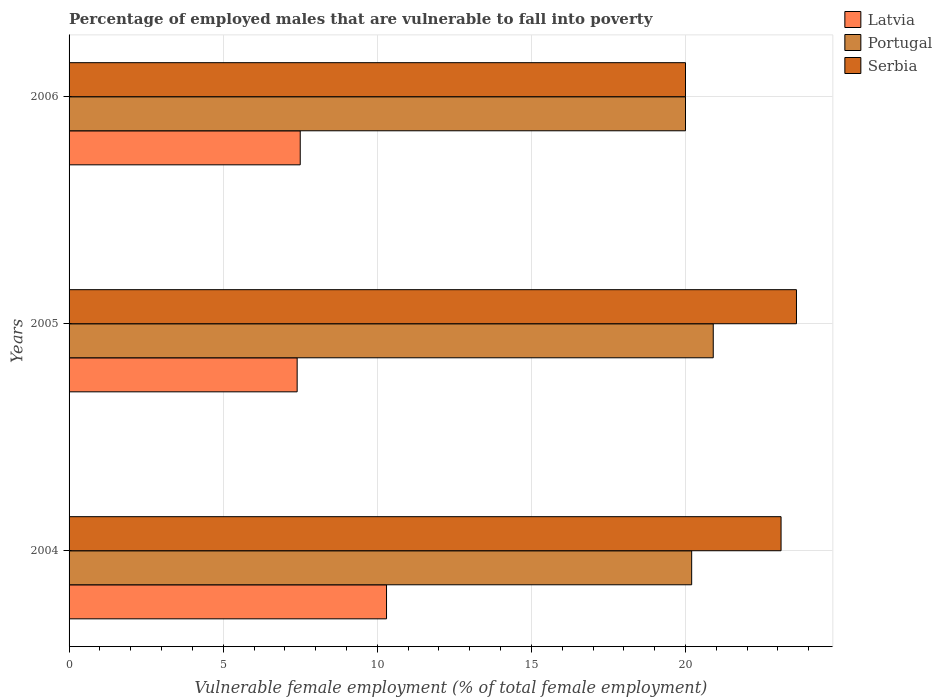How many different coloured bars are there?
Offer a terse response. 3. How many groups of bars are there?
Give a very brief answer. 3. Are the number of bars on each tick of the Y-axis equal?
Your answer should be compact. Yes. How many bars are there on the 2nd tick from the top?
Your answer should be very brief. 3. What is the label of the 1st group of bars from the top?
Keep it short and to the point. 2006. In how many cases, is the number of bars for a given year not equal to the number of legend labels?
Offer a terse response. 0. What is the percentage of employed males who are vulnerable to fall into poverty in Latvia in 2006?
Your response must be concise. 7.5. Across all years, what is the maximum percentage of employed males who are vulnerable to fall into poverty in Serbia?
Your response must be concise. 23.6. Across all years, what is the minimum percentage of employed males who are vulnerable to fall into poverty in Latvia?
Ensure brevity in your answer.  7.4. In which year was the percentage of employed males who are vulnerable to fall into poverty in Latvia minimum?
Ensure brevity in your answer.  2005. What is the total percentage of employed males who are vulnerable to fall into poverty in Latvia in the graph?
Offer a terse response. 25.2. What is the difference between the percentage of employed males who are vulnerable to fall into poverty in Latvia in 2004 and the percentage of employed males who are vulnerable to fall into poverty in Portugal in 2006?
Provide a short and direct response. -9.7. What is the average percentage of employed males who are vulnerable to fall into poverty in Portugal per year?
Your answer should be compact. 20.37. In the year 2004, what is the difference between the percentage of employed males who are vulnerable to fall into poverty in Serbia and percentage of employed males who are vulnerable to fall into poverty in Portugal?
Offer a very short reply. 2.9. In how many years, is the percentage of employed males who are vulnerable to fall into poverty in Portugal greater than 5 %?
Ensure brevity in your answer.  3. What is the ratio of the percentage of employed males who are vulnerable to fall into poverty in Portugal in 2004 to that in 2006?
Provide a succinct answer. 1.01. What is the difference between the highest and the second highest percentage of employed males who are vulnerable to fall into poverty in Latvia?
Keep it short and to the point. 2.8. What is the difference between the highest and the lowest percentage of employed males who are vulnerable to fall into poverty in Portugal?
Your answer should be compact. 0.9. In how many years, is the percentage of employed males who are vulnerable to fall into poverty in Serbia greater than the average percentage of employed males who are vulnerable to fall into poverty in Serbia taken over all years?
Offer a very short reply. 2. Is the sum of the percentage of employed males who are vulnerable to fall into poverty in Serbia in 2004 and 2005 greater than the maximum percentage of employed males who are vulnerable to fall into poverty in Latvia across all years?
Ensure brevity in your answer.  Yes. What does the 3rd bar from the top in 2004 represents?
Offer a terse response. Latvia. What does the 1st bar from the bottom in 2005 represents?
Keep it short and to the point. Latvia. Is it the case that in every year, the sum of the percentage of employed males who are vulnerable to fall into poverty in Portugal and percentage of employed males who are vulnerable to fall into poverty in Latvia is greater than the percentage of employed males who are vulnerable to fall into poverty in Serbia?
Offer a terse response. Yes. How many years are there in the graph?
Make the answer very short. 3. Does the graph contain any zero values?
Keep it short and to the point. No. Does the graph contain grids?
Provide a short and direct response. Yes. What is the title of the graph?
Ensure brevity in your answer.  Percentage of employed males that are vulnerable to fall into poverty. Does "Faeroe Islands" appear as one of the legend labels in the graph?
Provide a succinct answer. No. What is the label or title of the X-axis?
Give a very brief answer. Vulnerable female employment (% of total female employment). What is the label or title of the Y-axis?
Your answer should be very brief. Years. What is the Vulnerable female employment (% of total female employment) of Latvia in 2004?
Give a very brief answer. 10.3. What is the Vulnerable female employment (% of total female employment) of Portugal in 2004?
Offer a terse response. 20.2. What is the Vulnerable female employment (% of total female employment) in Serbia in 2004?
Your response must be concise. 23.1. What is the Vulnerable female employment (% of total female employment) in Latvia in 2005?
Offer a very short reply. 7.4. What is the Vulnerable female employment (% of total female employment) of Portugal in 2005?
Provide a succinct answer. 20.9. What is the Vulnerable female employment (% of total female employment) in Serbia in 2005?
Provide a short and direct response. 23.6. What is the Vulnerable female employment (% of total female employment) in Portugal in 2006?
Give a very brief answer. 20. Across all years, what is the maximum Vulnerable female employment (% of total female employment) of Latvia?
Your answer should be very brief. 10.3. Across all years, what is the maximum Vulnerable female employment (% of total female employment) in Portugal?
Provide a succinct answer. 20.9. Across all years, what is the maximum Vulnerable female employment (% of total female employment) of Serbia?
Your answer should be very brief. 23.6. Across all years, what is the minimum Vulnerable female employment (% of total female employment) in Latvia?
Your answer should be very brief. 7.4. What is the total Vulnerable female employment (% of total female employment) in Latvia in the graph?
Your response must be concise. 25.2. What is the total Vulnerable female employment (% of total female employment) of Portugal in the graph?
Your answer should be very brief. 61.1. What is the total Vulnerable female employment (% of total female employment) in Serbia in the graph?
Your answer should be very brief. 66.7. What is the difference between the Vulnerable female employment (% of total female employment) of Latvia in 2004 and that in 2005?
Offer a very short reply. 2.9. What is the difference between the Vulnerable female employment (% of total female employment) of Portugal in 2004 and that in 2005?
Make the answer very short. -0.7. What is the difference between the Vulnerable female employment (% of total female employment) in Serbia in 2004 and that in 2005?
Make the answer very short. -0.5. What is the difference between the Vulnerable female employment (% of total female employment) of Latvia in 2004 and that in 2006?
Provide a short and direct response. 2.8. What is the difference between the Vulnerable female employment (% of total female employment) in Serbia in 2004 and that in 2006?
Give a very brief answer. 3.1. What is the difference between the Vulnerable female employment (% of total female employment) of Portugal in 2005 and that in 2006?
Provide a succinct answer. 0.9. What is the difference between the Vulnerable female employment (% of total female employment) of Serbia in 2005 and that in 2006?
Your answer should be compact. 3.6. What is the difference between the Vulnerable female employment (% of total female employment) in Latvia in 2004 and the Vulnerable female employment (% of total female employment) in Portugal in 2005?
Ensure brevity in your answer.  -10.6. What is the difference between the Vulnerable female employment (% of total female employment) of Portugal in 2004 and the Vulnerable female employment (% of total female employment) of Serbia in 2005?
Give a very brief answer. -3.4. What is the difference between the Vulnerable female employment (% of total female employment) of Latvia in 2004 and the Vulnerable female employment (% of total female employment) of Portugal in 2006?
Make the answer very short. -9.7. What is the difference between the Vulnerable female employment (% of total female employment) in Portugal in 2004 and the Vulnerable female employment (% of total female employment) in Serbia in 2006?
Keep it short and to the point. 0.2. What is the difference between the Vulnerable female employment (% of total female employment) of Latvia in 2005 and the Vulnerable female employment (% of total female employment) of Portugal in 2006?
Keep it short and to the point. -12.6. What is the difference between the Vulnerable female employment (% of total female employment) of Latvia in 2005 and the Vulnerable female employment (% of total female employment) of Serbia in 2006?
Ensure brevity in your answer.  -12.6. What is the average Vulnerable female employment (% of total female employment) in Latvia per year?
Give a very brief answer. 8.4. What is the average Vulnerable female employment (% of total female employment) of Portugal per year?
Keep it short and to the point. 20.37. What is the average Vulnerable female employment (% of total female employment) in Serbia per year?
Ensure brevity in your answer.  22.23. In the year 2004, what is the difference between the Vulnerable female employment (% of total female employment) in Latvia and Vulnerable female employment (% of total female employment) in Portugal?
Make the answer very short. -9.9. In the year 2004, what is the difference between the Vulnerable female employment (% of total female employment) in Portugal and Vulnerable female employment (% of total female employment) in Serbia?
Offer a very short reply. -2.9. In the year 2005, what is the difference between the Vulnerable female employment (% of total female employment) in Latvia and Vulnerable female employment (% of total female employment) in Portugal?
Provide a short and direct response. -13.5. In the year 2005, what is the difference between the Vulnerable female employment (% of total female employment) of Latvia and Vulnerable female employment (% of total female employment) of Serbia?
Your answer should be very brief. -16.2. In the year 2005, what is the difference between the Vulnerable female employment (% of total female employment) of Portugal and Vulnerable female employment (% of total female employment) of Serbia?
Give a very brief answer. -2.7. In the year 2006, what is the difference between the Vulnerable female employment (% of total female employment) of Latvia and Vulnerable female employment (% of total female employment) of Serbia?
Offer a terse response. -12.5. In the year 2006, what is the difference between the Vulnerable female employment (% of total female employment) in Portugal and Vulnerable female employment (% of total female employment) in Serbia?
Your response must be concise. 0. What is the ratio of the Vulnerable female employment (% of total female employment) in Latvia in 2004 to that in 2005?
Your response must be concise. 1.39. What is the ratio of the Vulnerable female employment (% of total female employment) of Portugal in 2004 to that in 2005?
Ensure brevity in your answer.  0.97. What is the ratio of the Vulnerable female employment (% of total female employment) in Serbia in 2004 to that in 2005?
Provide a short and direct response. 0.98. What is the ratio of the Vulnerable female employment (% of total female employment) in Latvia in 2004 to that in 2006?
Make the answer very short. 1.37. What is the ratio of the Vulnerable female employment (% of total female employment) in Serbia in 2004 to that in 2006?
Provide a short and direct response. 1.16. What is the ratio of the Vulnerable female employment (% of total female employment) in Latvia in 2005 to that in 2006?
Offer a very short reply. 0.99. What is the ratio of the Vulnerable female employment (% of total female employment) of Portugal in 2005 to that in 2006?
Give a very brief answer. 1.04. What is the ratio of the Vulnerable female employment (% of total female employment) in Serbia in 2005 to that in 2006?
Offer a very short reply. 1.18. What is the difference between the highest and the second highest Vulnerable female employment (% of total female employment) of Latvia?
Provide a short and direct response. 2.8. What is the difference between the highest and the second highest Vulnerable female employment (% of total female employment) in Portugal?
Your answer should be compact. 0.7. What is the difference between the highest and the lowest Vulnerable female employment (% of total female employment) of Latvia?
Ensure brevity in your answer.  2.9. What is the difference between the highest and the lowest Vulnerable female employment (% of total female employment) in Serbia?
Give a very brief answer. 3.6. 